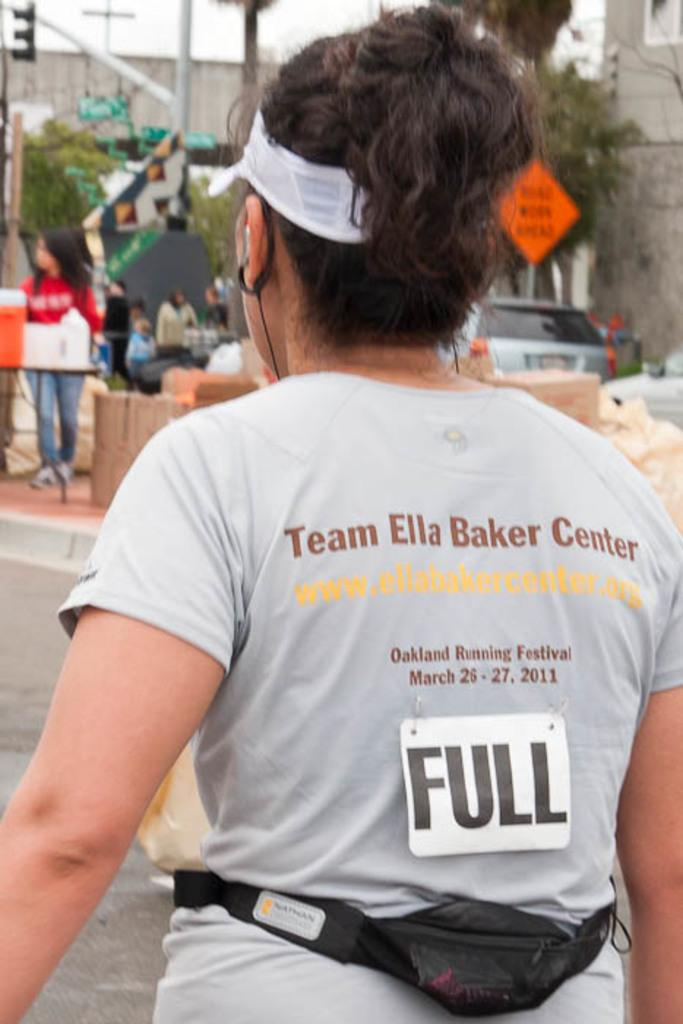<image>
Write a terse but informative summary of the picture. A woman wears a shirt that says Team Ella Baker Center on the back. 